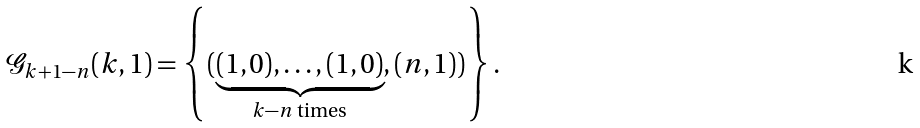Convert formula to latex. <formula><loc_0><loc_0><loc_500><loc_500>\mathcal { G } _ { k + 1 - n } ( k , 1 ) = \left \{ ( \underbrace { ( 1 , 0 ) , \dots , ( 1 , 0 ) } _ { k - n \text { times} } , ( n , 1 ) ) \right \} .</formula> 